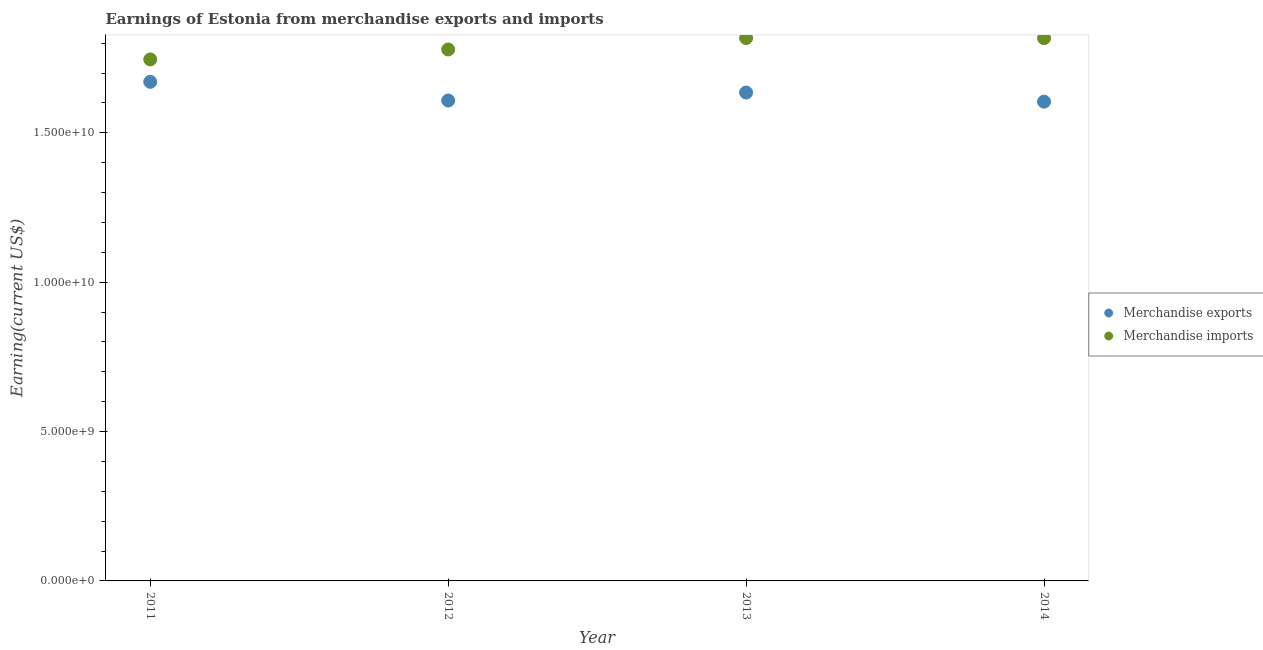What is the earnings from merchandise exports in 2014?
Give a very brief answer. 1.60e+1. Across all years, what is the maximum earnings from merchandise exports?
Your answer should be compact. 1.67e+1. Across all years, what is the minimum earnings from merchandise exports?
Provide a short and direct response. 1.60e+1. What is the total earnings from merchandise exports in the graph?
Keep it short and to the point. 6.52e+1. What is the difference between the earnings from merchandise exports in 2013 and that in 2014?
Your response must be concise. 3.05e+08. What is the difference between the earnings from merchandise exports in 2011 and the earnings from merchandise imports in 2013?
Keep it short and to the point. -1.46e+09. What is the average earnings from merchandise exports per year?
Provide a succinct answer. 1.63e+1. In the year 2012, what is the difference between the earnings from merchandise imports and earnings from merchandise exports?
Offer a terse response. 1.71e+09. What is the ratio of the earnings from merchandise exports in 2013 to that in 2014?
Your answer should be very brief. 1.02. What is the difference between the highest and the second highest earnings from merchandise exports?
Provide a short and direct response. 3.59e+08. What is the difference between the highest and the lowest earnings from merchandise exports?
Your answer should be compact. 6.64e+08. How many dotlines are there?
Your response must be concise. 2. How many years are there in the graph?
Keep it short and to the point. 4. What is the difference between two consecutive major ticks on the Y-axis?
Provide a succinct answer. 5.00e+09. Are the values on the major ticks of Y-axis written in scientific E-notation?
Provide a succinct answer. Yes. Does the graph contain any zero values?
Make the answer very short. No. Where does the legend appear in the graph?
Your answer should be compact. Center right. How are the legend labels stacked?
Give a very brief answer. Vertical. What is the title of the graph?
Your response must be concise. Earnings of Estonia from merchandise exports and imports. What is the label or title of the X-axis?
Offer a terse response. Year. What is the label or title of the Y-axis?
Your answer should be compact. Earning(current US$). What is the Earning(current US$) in Merchandise exports in 2011?
Your answer should be compact. 1.67e+1. What is the Earning(current US$) of Merchandise imports in 2011?
Your answer should be very brief. 1.75e+1. What is the Earning(current US$) of Merchandise exports in 2012?
Provide a short and direct response. 1.61e+1. What is the Earning(current US$) of Merchandise imports in 2012?
Ensure brevity in your answer.  1.78e+1. What is the Earning(current US$) of Merchandise exports in 2013?
Keep it short and to the point. 1.63e+1. What is the Earning(current US$) of Merchandise imports in 2013?
Provide a short and direct response. 1.82e+1. What is the Earning(current US$) of Merchandise exports in 2014?
Provide a short and direct response. 1.60e+1. What is the Earning(current US$) in Merchandise imports in 2014?
Give a very brief answer. 1.82e+1. Across all years, what is the maximum Earning(current US$) in Merchandise exports?
Offer a very short reply. 1.67e+1. Across all years, what is the maximum Earning(current US$) of Merchandise imports?
Offer a very short reply. 1.82e+1. Across all years, what is the minimum Earning(current US$) of Merchandise exports?
Make the answer very short. 1.60e+1. Across all years, what is the minimum Earning(current US$) in Merchandise imports?
Your answer should be very brief. 1.75e+1. What is the total Earning(current US$) in Merchandise exports in the graph?
Keep it short and to the point. 6.52e+1. What is the total Earning(current US$) of Merchandise imports in the graph?
Ensure brevity in your answer.  7.16e+1. What is the difference between the Earning(current US$) of Merchandise exports in 2011 and that in 2012?
Your response must be concise. 6.25e+08. What is the difference between the Earning(current US$) of Merchandise imports in 2011 and that in 2012?
Make the answer very short. -3.32e+08. What is the difference between the Earning(current US$) of Merchandise exports in 2011 and that in 2013?
Keep it short and to the point. 3.59e+08. What is the difference between the Earning(current US$) in Merchandise imports in 2011 and that in 2013?
Offer a very short reply. -7.15e+08. What is the difference between the Earning(current US$) in Merchandise exports in 2011 and that in 2014?
Make the answer very short. 6.64e+08. What is the difference between the Earning(current US$) in Merchandise imports in 2011 and that in 2014?
Your answer should be compact. -7.10e+08. What is the difference between the Earning(current US$) in Merchandise exports in 2012 and that in 2013?
Your answer should be very brief. -2.66e+08. What is the difference between the Earning(current US$) in Merchandise imports in 2012 and that in 2013?
Offer a very short reply. -3.82e+08. What is the difference between the Earning(current US$) of Merchandise exports in 2012 and that in 2014?
Provide a short and direct response. 3.91e+07. What is the difference between the Earning(current US$) in Merchandise imports in 2012 and that in 2014?
Keep it short and to the point. -3.78e+08. What is the difference between the Earning(current US$) of Merchandise exports in 2013 and that in 2014?
Provide a succinct answer. 3.05e+08. What is the difference between the Earning(current US$) in Merchandise imports in 2013 and that in 2014?
Give a very brief answer. 4.62e+06. What is the difference between the Earning(current US$) in Merchandise exports in 2011 and the Earning(current US$) in Merchandise imports in 2012?
Make the answer very short. -1.08e+09. What is the difference between the Earning(current US$) of Merchandise exports in 2011 and the Earning(current US$) of Merchandise imports in 2013?
Ensure brevity in your answer.  -1.46e+09. What is the difference between the Earning(current US$) in Merchandise exports in 2011 and the Earning(current US$) in Merchandise imports in 2014?
Offer a very short reply. -1.46e+09. What is the difference between the Earning(current US$) in Merchandise exports in 2012 and the Earning(current US$) in Merchandise imports in 2013?
Offer a terse response. -2.09e+09. What is the difference between the Earning(current US$) in Merchandise exports in 2012 and the Earning(current US$) in Merchandise imports in 2014?
Keep it short and to the point. -2.09e+09. What is the difference between the Earning(current US$) of Merchandise exports in 2013 and the Earning(current US$) of Merchandise imports in 2014?
Provide a succinct answer. -1.82e+09. What is the average Earning(current US$) of Merchandise exports per year?
Offer a terse response. 1.63e+1. What is the average Earning(current US$) of Merchandise imports per year?
Provide a succinct answer. 1.79e+1. In the year 2011, what is the difference between the Earning(current US$) in Merchandise exports and Earning(current US$) in Merchandise imports?
Provide a succinct answer. -7.50e+08. In the year 2012, what is the difference between the Earning(current US$) in Merchandise exports and Earning(current US$) in Merchandise imports?
Provide a succinct answer. -1.71e+09. In the year 2013, what is the difference between the Earning(current US$) in Merchandise exports and Earning(current US$) in Merchandise imports?
Give a very brief answer. -1.82e+09. In the year 2014, what is the difference between the Earning(current US$) in Merchandise exports and Earning(current US$) in Merchandise imports?
Offer a very short reply. -2.12e+09. What is the ratio of the Earning(current US$) of Merchandise exports in 2011 to that in 2012?
Your answer should be very brief. 1.04. What is the ratio of the Earning(current US$) of Merchandise imports in 2011 to that in 2012?
Your answer should be compact. 0.98. What is the ratio of the Earning(current US$) of Merchandise imports in 2011 to that in 2013?
Offer a very short reply. 0.96. What is the ratio of the Earning(current US$) in Merchandise exports in 2011 to that in 2014?
Give a very brief answer. 1.04. What is the ratio of the Earning(current US$) of Merchandise imports in 2011 to that in 2014?
Your answer should be very brief. 0.96. What is the ratio of the Earning(current US$) of Merchandise exports in 2012 to that in 2013?
Offer a very short reply. 0.98. What is the ratio of the Earning(current US$) in Merchandise imports in 2012 to that in 2013?
Your response must be concise. 0.98. What is the ratio of the Earning(current US$) in Merchandise imports in 2012 to that in 2014?
Offer a terse response. 0.98. What is the ratio of the Earning(current US$) of Merchandise imports in 2013 to that in 2014?
Offer a terse response. 1. What is the difference between the highest and the second highest Earning(current US$) in Merchandise exports?
Your answer should be compact. 3.59e+08. What is the difference between the highest and the second highest Earning(current US$) of Merchandise imports?
Your answer should be very brief. 4.62e+06. What is the difference between the highest and the lowest Earning(current US$) in Merchandise exports?
Provide a succinct answer. 6.64e+08. What is the difference between the highest and the lowest Earning(current US$) in Merchandise imports?
Offer a very short reply. 7.15e+08. 